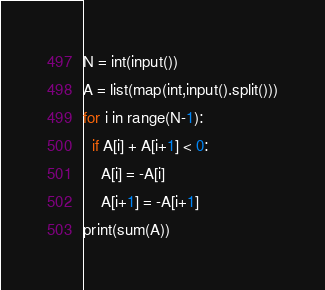<code> <loc_0><loc_0><loc_500><loc_500><_Python_>N = int(input())
A = list(map(int,input().split()))
for i in range(N-1):
  if A[i] + A[i+1] < 0:
    A[i] = -A[i]
    A[i+1] = -A[i+1]
print(sum(A))</code> 